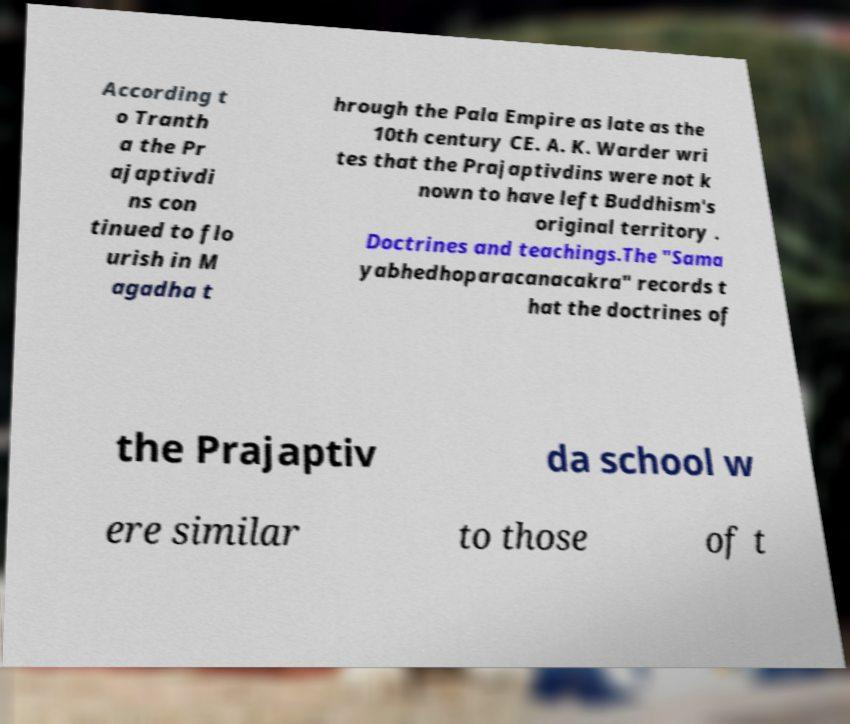Could you extract and type out the text from this image? According t o Tranth a the Pr ajaptivdi ns con tinued to flo urish in M agadha t hrough the Pala Empire as late as the 10th century CE. A. K. Warder wri tes that the Prajaptivdins were not k nown to have left Buddhism's original territory . Doctrines and teachings.The "Sama yabhedhoparacanacakra" records t hat the doctrines of the Prajaptiv da school w ere similar to those of t 